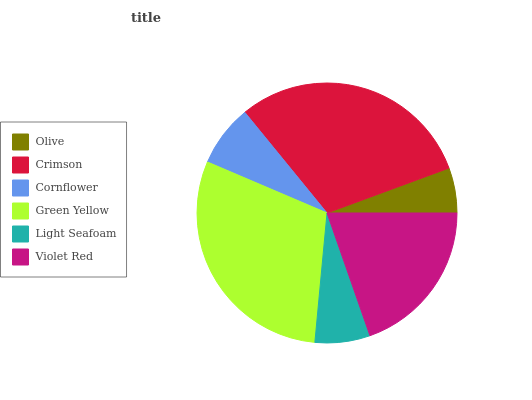Is Olive the minimum?
Answer yes or no. Yes. Is Crimson the maximum?
Answer yes or no. Yes. Is Cornflower the minimum?
Answer yes or no. No. Is Cornflower the maximum?
Answer yes or no. No. Is Crimson greater than Cornflower?
Answer yes or no. Yes. Is Cornflower less than Crimson?
Answer yes or no. Yes. Is Cornflower greater than Crimson?
Answer yes or no. No. Is Crimson less than Cornflower?
Answer yes or no. No. Is Violet Red the high median?
Answer yes or no. Yes. Is Cornflower the low median?
Answer yes or no. Yes. Is Crimson the high median?
Answer yes or no. No. Is Green Yellow the low median?
Answer yes or no. No. 